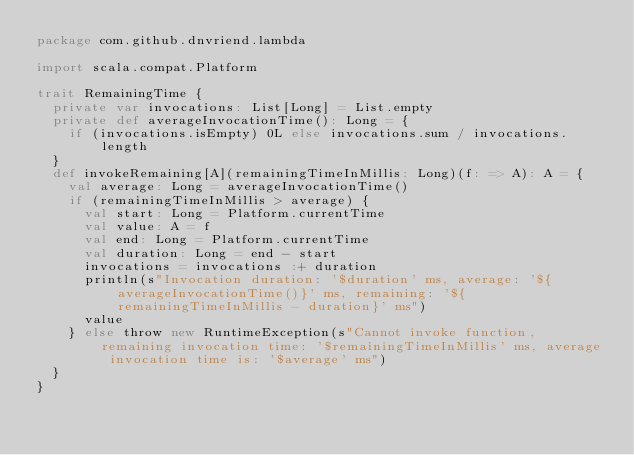<code> <loc_0><loc_0><loc_500><loc_500><_Scala_>package com.github.dnvriend.lambda

import scala.compat.Platform

trait RemainingTime {
  private var invocations: List[Long] = List.empty
  private def averageInvocationTime(): Long = {
    if (invocations.isEmpty) 0L else invocations.sum / invocations.length
  }
  def invokeRemaining[A](remainingTimeInMillis: Long)(f: => A): A = {
    val average: Long = averageInvocationTime()
    if (remainingTimeInMillis > average) {
      val start: Long = Platform.currentTime
      val value: A = f
      val end: Long = Platform.currentTime
      val duration: Long = end - start
      invocations = invocations :+ duration
      println(s"Invocation duration: '$duration' ms, average: '${averageInvocationTime()}' ms, remaining: '${remainingTimeInMillis - duration}' ms")
      value
    } else throw new RuntimeException(s"Cannot invoke function, remaining invocation time: '$remainingTimeInMillis' ms, average invocation time is: '$average' ms")
  }
}
</code> 